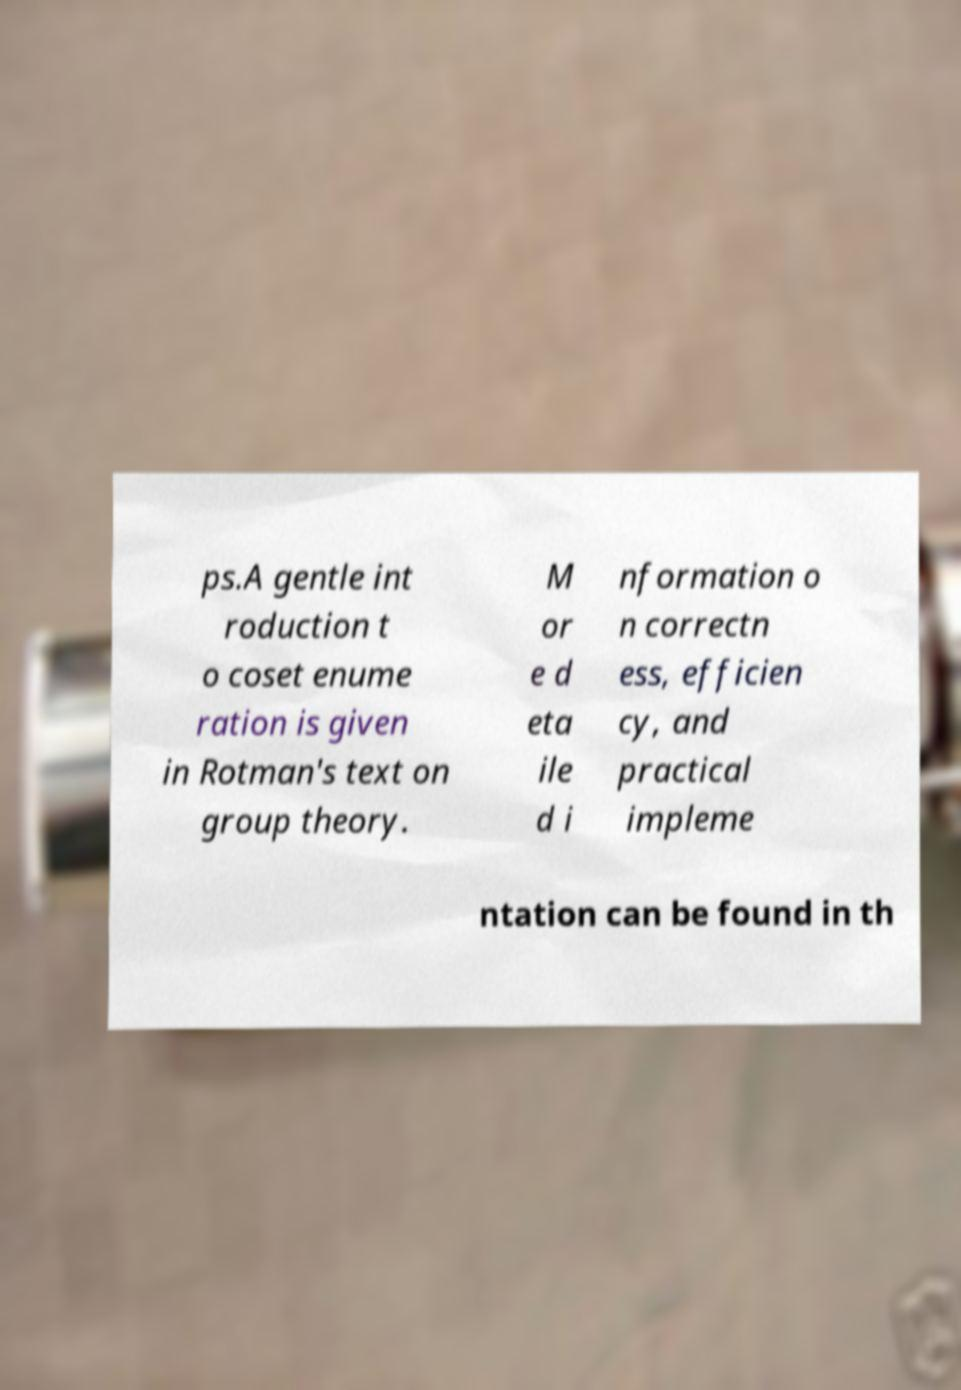Can you accurately transcribe the text from the provided image for me? ps.A gentle int roduction t o coset enume ration is given in Rotman's text on group theory. M or e d eta ile d i nformation o n correctn ess, efficien cy, and practical impleme ntation can be found in th 